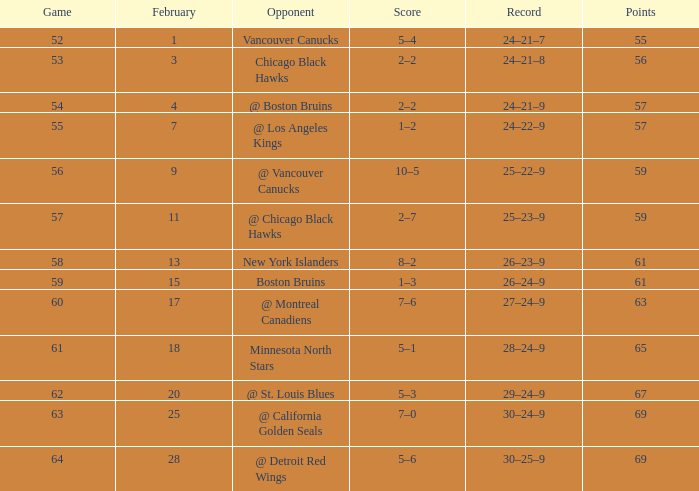How many games hold a 30-25-9 record and a score higher than 69? 0.0. 